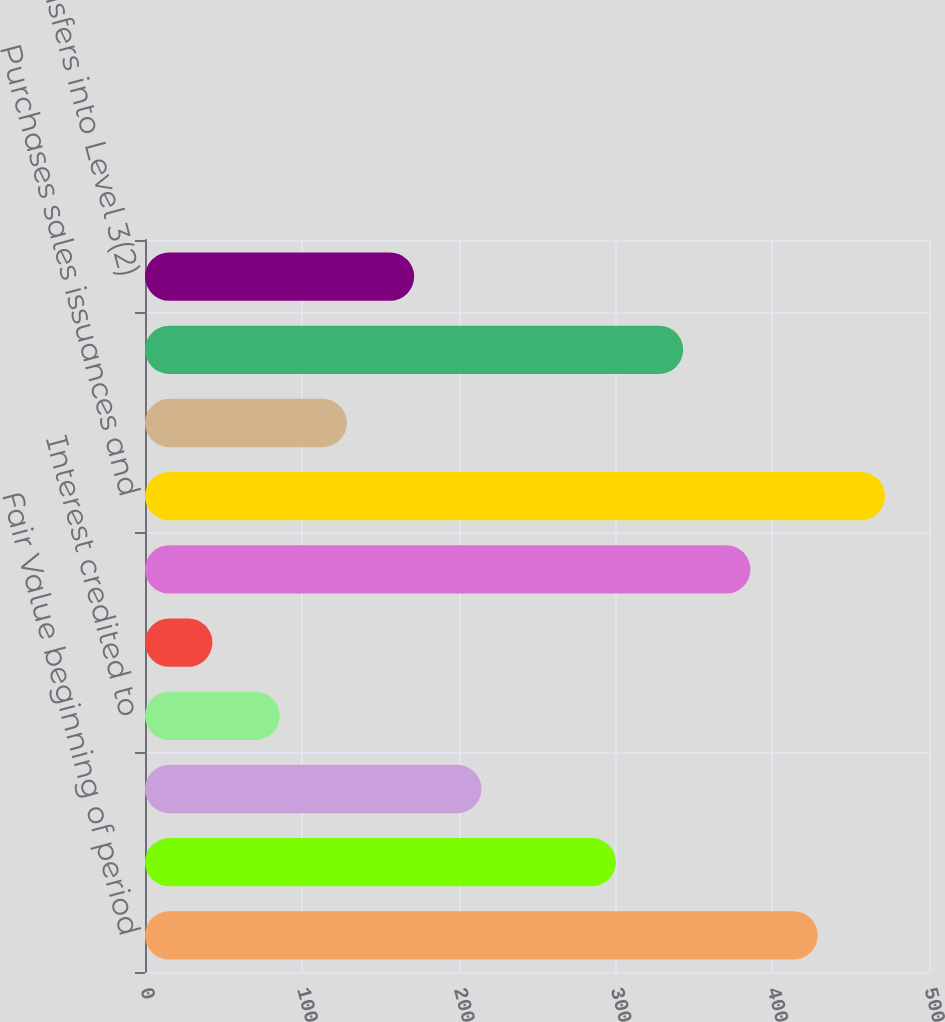Convert chart to OTSL. <chart><loc_0><loc_0><loc_500><loc_500><bar_chart><fcel>Fair Value beginning of period<fcel>Realized investment gains<fcel>Asset management fees and<fcel>Interest credited to<fcel>Included in other<fcel>Net investment income<fcel>Purchases sales issuances and<fcel>Foreign currency translation<fcel>Other(1)<fcel>Transfers into Level 3(2)<nl><fcel>429.02<fcel>300.35<fcel>214.57<fcel>85.9<fcel>43.01<fcel>386.13<fcel>471.91<fcel>128.79<fcel>343.24<fcel>171.68<nl></chart> 